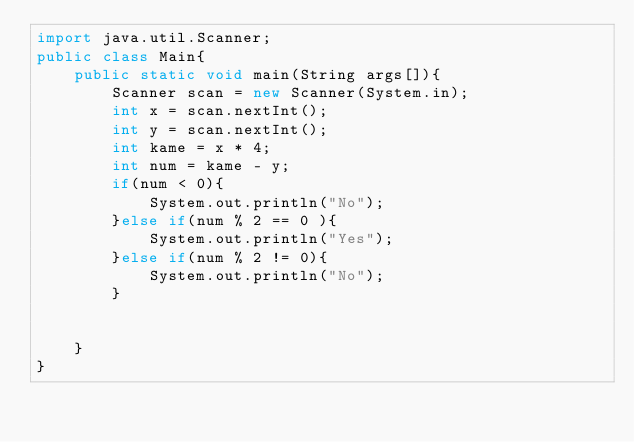Convert code to text. <code><loc_0><loc_0><loc_500><loc_500><_Java_>import java.util.Scanner;
public class Main{
    public static void main(String args[]){
        Scanner scan = new Scanner(System.in);
        int x = scan.nextInt();
        int y = scan.nextInt();
        int kame = x * 4;
        int num = kame - y;
        if(num < 0){
            System.out.println("No");
        }else if(num % 2 == 0 ){
            System.out.println("Yes");
        }else if(num % 2 != 0){
            System.out.println("No");
        }


    }
}</code> 